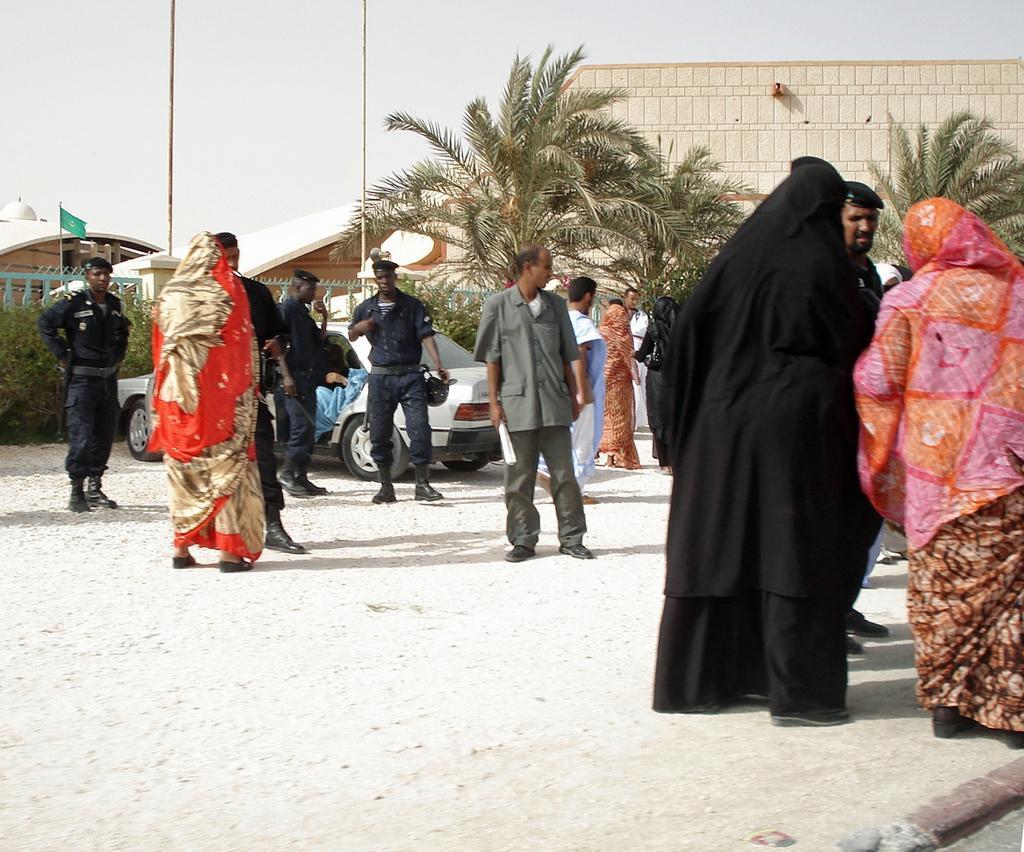Could you give a brief overview of what you see in this image? This picture is clicked outside. In the center we can see the group of people standing on the ground and we can see the group of people wearing uniforms and seems to be standing on the ground and we can see a car parked on the ground and we can see a person sitting in the car. In the background we can see the sky, poles, buildings, flag, tree, plants and some other objects. 